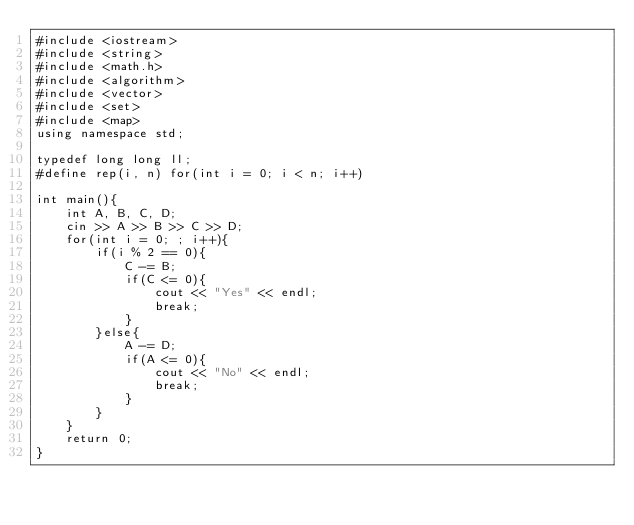Convert code to text. <code><loc_0><loc_0><loc_500><loc_500><_C++_>#include <iostream>
#include <string>
#include <math.h>
#include <algorithm>
#include <vector>
#include <set>
#include <map>
using namespace std;

typedef long long ll;
#define rep(i, n) for(int i = 0; i < n; i++)

int main(){
    int A, B, C, D;
    cin >> A >> B >> C >> D;
    for(int i = 0; ; i++){
        if(i % 2 == 0){
            C -= B;
            if(C <= 0){
                cout << "Yes" << endl;
                break;
            }
        }else{
            A -= D;
            if(A <= 0){
                cout << "No" << endl;
                break;
            }
        }
    }
    return 0;
}</code> 